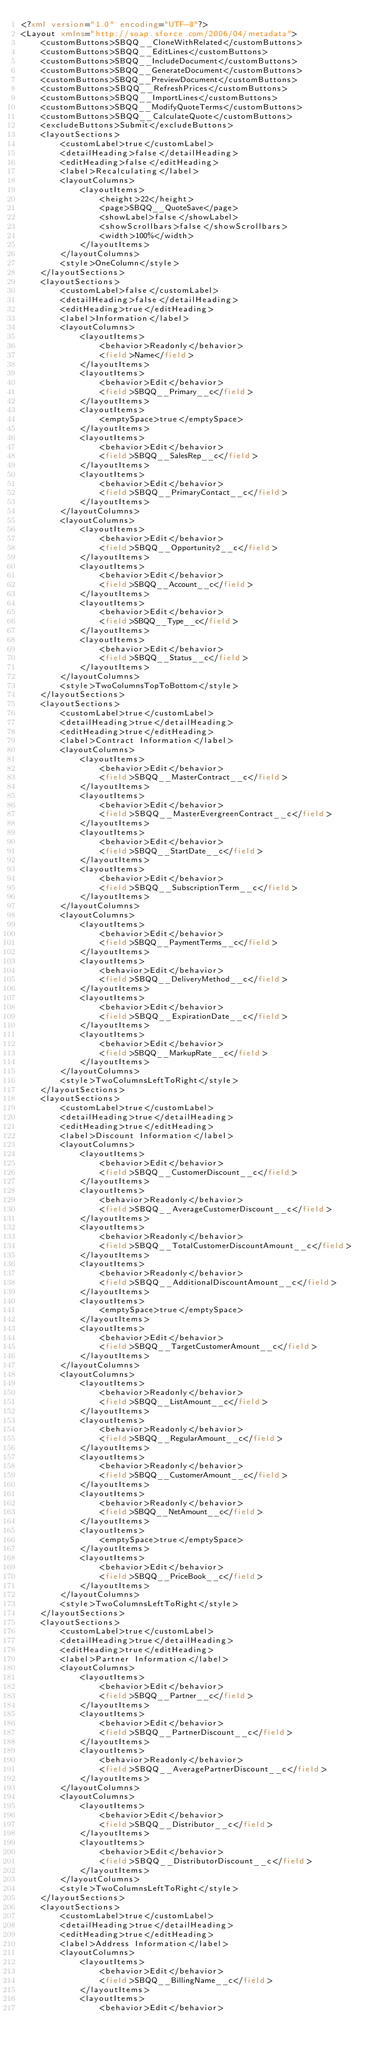Convert code to text. <code><loc_0><loc_0><loc_500><loc_500><_XML_><?xml version="1.0" encoding="UTF-8"?>
<Layout xmlns="http://soap.sforce.com/2006/04/metadata">
    <customButtons>SBQQ__CloneWithRelated</customButtons>
    <customButtons>SBQQ__EditLines</customButtons>
    <customButtons>SBQQ__IncludeDocument</customButtons>
    <customButtons>SBQQ__GenerateDocument</customButtons>
    <customButtons>SBQQ__PreviewDocument</customButtons>
    <customButtons>SBQQ__RefreshPrices</customButtons>
    <customButtons>SBQQ__ImportLines</customButtons>
    <customButtons>SBQQ__ModifyQuoteTerms</customButtons>
    <customButtons>SBQQ__CalculateQuote</customButtons>
    <excludeButtons>Submit</excludeButtons>
    <layoutSections>
        <customLabel>true</customLabel>
        <detailHeading>false</detailHeading>
        <editHeading>false</editHeading>
        <label>Recalculating</label>
        <layoutColumns>
            <layoutItems>
                <height>22</height>
                <page>SBQQ__QuoteSave</page>
                <showLabel>false</showLabel>
                <showScrollbars>false</showScrollbars>
                <width>100%</width>
            </layoutItems>
        </layoutColumns>
        <style>OneColumn</style>
    </layoutSections>
    <layoutSections>
        <customLabel>false</customLabel>
        <detailHeading>false</detailHeading>
        <editHeading>true</editHeading>
        <label>Information</label>
        <layoutColumns>
            <layoutItems>
                <behavior>Readonly</behavior>
                <field>Name</field>
            </layoutItems>
            <layoutItems>
                <behavior>Edit</behavior>
                <field>SBQQ__Primary__c</field>
            </layoutItems>
            <layoutItems>
                <emptySpace>true</emptySpace>
            </layoutItems>
            <layoutItems>
                <behavior>Edit</behavior>
                <field>SBQQ__SalesRep__c</field>
            </layoutItems>
            <layoutItems>
                <behavior>Edit</behavior>
                <field>SBQQ__PrimaryContact__c</field>
            </layoutItems>
        </layoutColumns>
        <layoutColumns>
            <layoutItems>
                <behavior>Edit</behavior>
                <field>SBQQ__Opportunity2__c</field>
            </layoutItems>
            <layoutItems>
                <behavior>Edit</behavior>
                <field>SBQQ__Account__c</field>
            </layoutItems>
            <layoutItems>
                <behavior>Edit</behavior>
                <field>SBQQ__Type__c</field>
            </layoutItems>
            <layoutItems>
                <behavior>Edit</behavior>
                <field>SBQQ__Status__c</field>
            </layoutItems>
        </layoutColumns>
        <style>TwoColumnsTopToBottom</style>
    </layoutSections>
    <layoutSections>
        <customLabel>true</customLabel>
        <detailHeading>true</detailHeading>
        <editHeading>true</editHeading>
        <label>Contract Information</label>
        <layoutColumns>
            <layoutItems>
                <behavior>Edit</behavior>
                <field>SBQQ__MasterContract__c</field>
            </layoutItems>
            <layoutItems>
                <behavior>Edit</behavior>
                <field>SBQQ__MasterEvergreenContract__c</field>
            </layoutItems>
            <layoutItems>
                <behavior>Edit</behavior>
                <field>SBQQ__StartDate__c</field>
            </layoutItems>
            <layoutItems>
                <behavior>Edit</behavior>
                <field>SBQQ__SubscriptionTerm__c</field>
            </layoutItems>
        </layoutColumns>
        <layoutColumns>
            <layoutItems>
                <behavior>Edit</behavior>
                <field>SBQQ__PaymentTerms__c</field>
            </layoutItems>
            <layoutItems>
                <behavior>Edit</behavior>
                <field>SBQQ__DeliveryMethod__c</field>
            </layoutItems>
            <layoutItems>
                <behavior>Edit</behavior>
                <field>SBQQ__ExpirationDate__c</field>
            </layoutItems>
            <layoutItems>
                <behavior>Edit</behavior>
                <field>SBQQ__MarkupRate__c</field>
            </layoutItems>
        </layoutColumns>
        <style>TwoColumnsLeftToRight</style>
    </layoutSections>
    <layoutSections>
        <customLabel>true</customLabel>
        <detailHeading>true</detailHeading>
        <editHeading>true</editHeading>
        <label>Discount Information</label>
        <layoutColumns>
            <layoutItems>
                <behavior>Edit</behavior>
                <field>SBQQ__CustomerDiscount__c</field>
            </layoutItems>
            <layoutItems>
                <behavior>Readonly</behavior>
                <field>SBQQ__AverageCustomerDiscount__c</field>
            </layoutItems>
            <layoutItems>
                <behavior>Readonly</behavior>
                <field>SBQQ__TotalCustomerDiscountAmount__c</field>
            </layoutItems>
            <layoutItems>
                <behavior>Readonly</behavior>
                <field>SBQQ__AdditionalDiscountAmount__c</field>
            </layoutItems>
            <layoutItems>
                <emptySpace>true</emptySpace>
            </layoutItems>
            <layoutItems>
                <behavior>Edit</behavior>
                <field>SBQQ__TargetCustomerAmount__c</field>
            </layoutItems>
        </layoutColumns>
        <layoutColumns>
            <layoutItems>
                <behavior>Readonly</behavior>
                <field>SBQQ__ListAmount__c</field>
            </layoutItems>
            <layoutItems>
                <behavior>Readonly</behavior>
                <field>SBQQ__RegularAmount__c</field>
            </layoutItems>
            <layoutItems>
                <behavior>Readonly</behavior>
                <field>SBQQ__CustomerAmount__c</field>
            </layoutItems>
            <layoutItems>
                <behavior>Readonly</behavior>
                <field>SBQQ__NetAmount__c</field>
            </layoutItems>
            <layoutItems>
                <emptySpace>true</emptySpace>
            </layoutItems>
            <layoutItems>
                <behavior>Edit</behavior>
                <field>SBQQ__PriceBook__c</field>
            </layoutItems>
        </layoutColumns>
        <style>TwoColumnsLeftToRight</style>
    </layoutSections>
    <layoutSections>
        <customLabel>true</customLabel>
        <detailHeading>true</detailHeading>
        <editHeading>true</editHeading>
        <label>Partner Information</label>
        <layoutColumns>
            <layoutItems>
                <behavior>Edit</behavior>
                <field>SBQQ__Partner__c</field>
            </layoutItems>
            <layoutItems>
                <behavior>Edit</behavior>
                <field>SBQQ__PartnerDiscount__c</field>
            </layoutItems>
            <layoutItems>
                <behavior>Readonly</behavior>
                <field>SBQQ__AveragePartnerDiscount__c</field>
            </layoutItems>
        </layoutColumns>
        <layoutColumns>
            <layoutItems>
                <behavior>Edit</behavior>
                <field>SBQQ__Distributor__c</field>
            </layoutItems>
            <layoutItems>
                <behavior>Edit</behavior>
                <field>SBQQ__DistributorDiscount__c</field>
            </layoutItems>
        </layoutColumns>
        <style>TwoColumnsLeftToRight</style>
    </layoutSections>
    <layoutSections>
        <customLabel>true</customLabel>
        <detailHeading>true</detailHeading>
        <editHeading>true</editHeading>
        <label>Address Information</label>
        <layoutColumns>
            <layoutItems>
                <behavior>Edit</behavior>
                <field>SBQQ__BillingName__c</field>
            </layoutItems>
            <layoutItems>
                <behavior>Edit</behavior></code> 